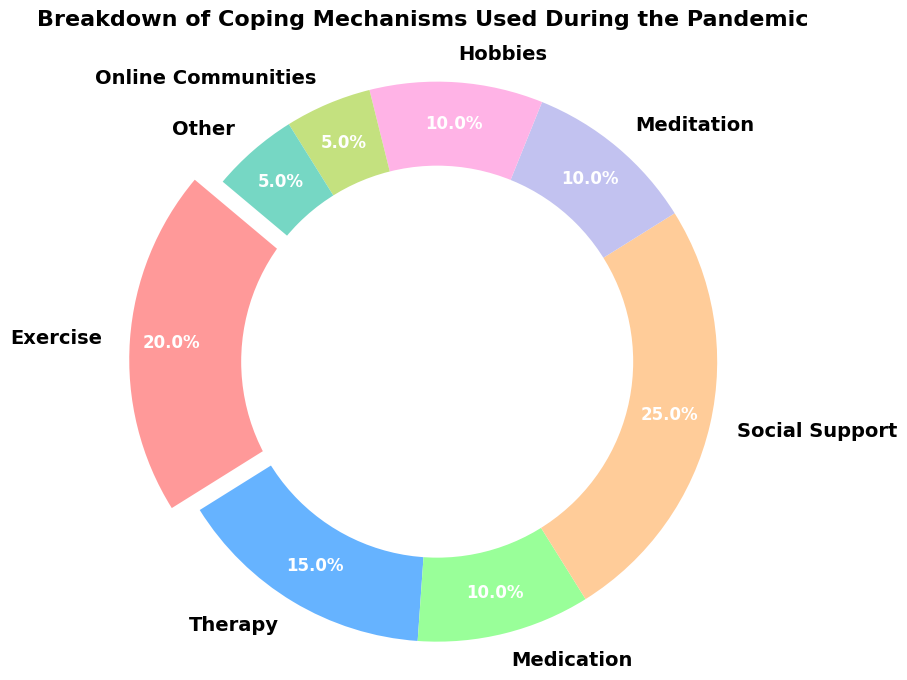what coping mechanism category has the highest percentage? The largest section of the pie chart belongs to "Social Support". The visual representation shows "Social Support" occupies the largest proportion compared to the others.
Answer: Social Support How does the percentage of people using exercise compare to those using therapy? The percentage of people using exercise is 20%, whereas the percentage using therapy is 15%. Exercise has a higher percentage than therapy.
Answer: Exercise is higher What is the combined percentage of people using medication and meditation? The percentage of people using medication is 10%, and the percentage of people using meditation is also 10%. Adding them together, the combined percentage is 10% + 10% = 20%.
Answer: 20% Which coping mechanism has the smallest representation on the chart? The smallest sections of the pie chart are those for "Online Communities" and "Other", both representing 5% each.
Answer: Online Communities and Other Compare the combined percentage of "Hobbies" and "Online Communities" to "Exercise". "Hobbies" represents 10% and "Online Communities" represents 5%. The combined percentage is 10% + 5% = 15%. In comparison, "Exercise" alone represents 20%. Thus, "Exercise" has a higher percentage than the combined "Hobbies" and "Online Communities".
Answer: Exercise is higher What is the percentage difference between "Social Support" and "Meditation"? "Social Support" represents 25%, while "Meditation" represents 10%. The difference is 25% - 10% = 15%.
Answer: 15% Rank the coping mechanisms from highest to lowest percentage. Observing the pie chart, the ranking from highest to lowest percentage is: Social Support (25%), Exercise (20%), Therapy (15%), Medication (10%), Meditation (10%), Hobbies (10%), Online Communities (5%), Other (5%).
Answer: Social Support, Exercise, Therapy, Medication, Meditation, Hobbies, Online Communities, Other Which portion is highlighted or exploded in the pie chart? The section of the pie chart that is highlighted or exploded is the one representing "Exercise". This visual design decision emphasizes "Exercise".
Answer: Exercise What percentage of coping mechanisms not involving direct social interaction (Exercise, Meditation, Hobbies, etc.) is represented on the chart? Summing the percentages for Exercise (20%), Medication (10%), Meditation (10%), Hobbies (10%), and Online Communities (5%), the total is 20% + 10% + 10% + 10% + 5% = 55%.
Answer: 55% If you were to combine all categories related to direct social interaction (Social Support and Online Communities), what percentage would they make up? Combining "Social Support" (25%) and "Online Communities" (5%), the total is 25% + 5% = 30%.
Answer: 30% 